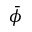<formula> <loc_0><loc_0><loc_500><loc_500>\bar { \phi }</formula> 